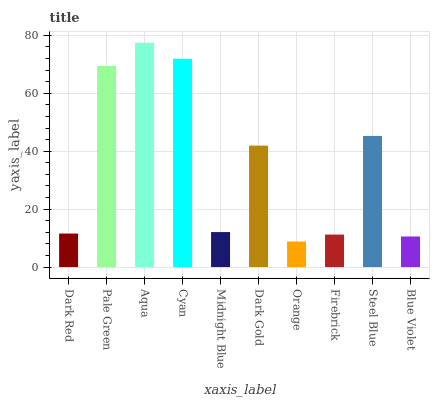Is Pale Green the minimum?
Answer yes or no. No. Is Pale Green the maximum?
Answer yes or no. No. Is Pale Green greater than Dark Red?
Answer yes or no. Yes. Is Dark Red less than Pale Green?
Answer yes or no. Yes. Is Dark Red greater than Pale Green?
Answer yes or no. No. Is Pale Green less than Dark Red?
Answer yes or no. No. Is Dark Gold the high median?
Answer yes or no. Yes. Is Midnight Blue the low median?
Answer yes or no. Yes. Is Orange the high median?
Answer yes or no. No. Is Cyan the low median?
Answer yes or no. No. 